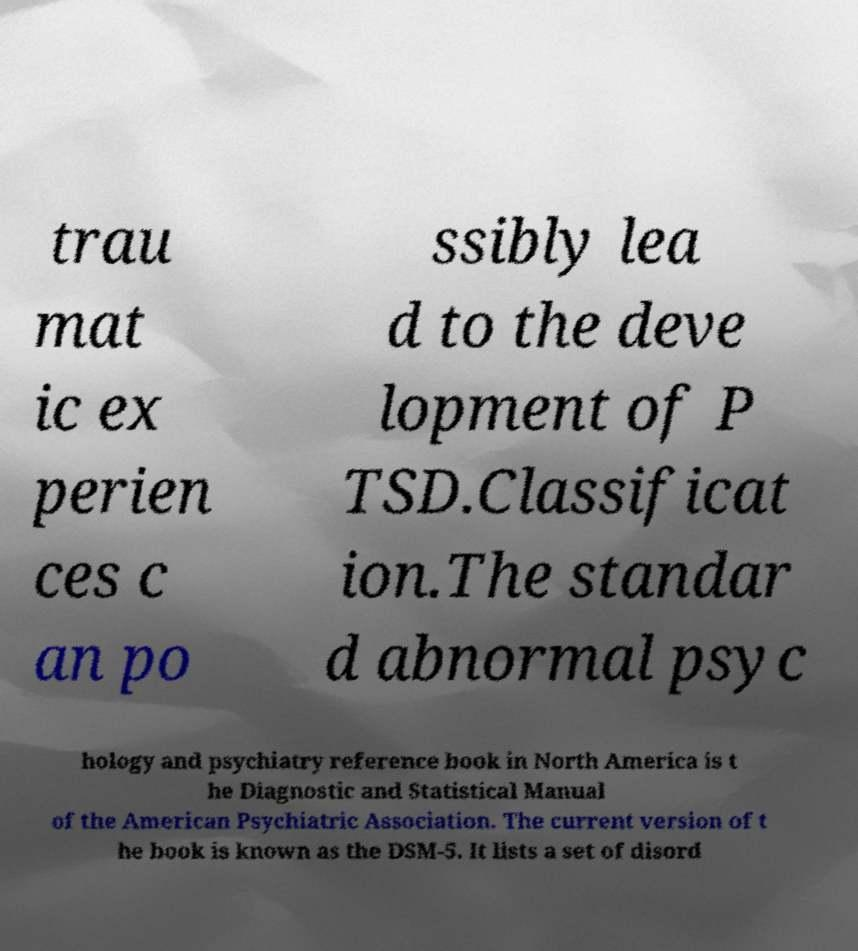Could you assist in decoding the text presented in this image and type it out clearly? trau mat ic ex perien ces c an po ssibly lea d to the deve lopment of P TSD.Classificat ion.The standar d abnormal psyc hology and psychiatry reference book in North America is t he Diagnostic and Statistical Manual of the American Psychiatric Association. The current version of t he book is known as the DSM-5. It lists a set of disord 